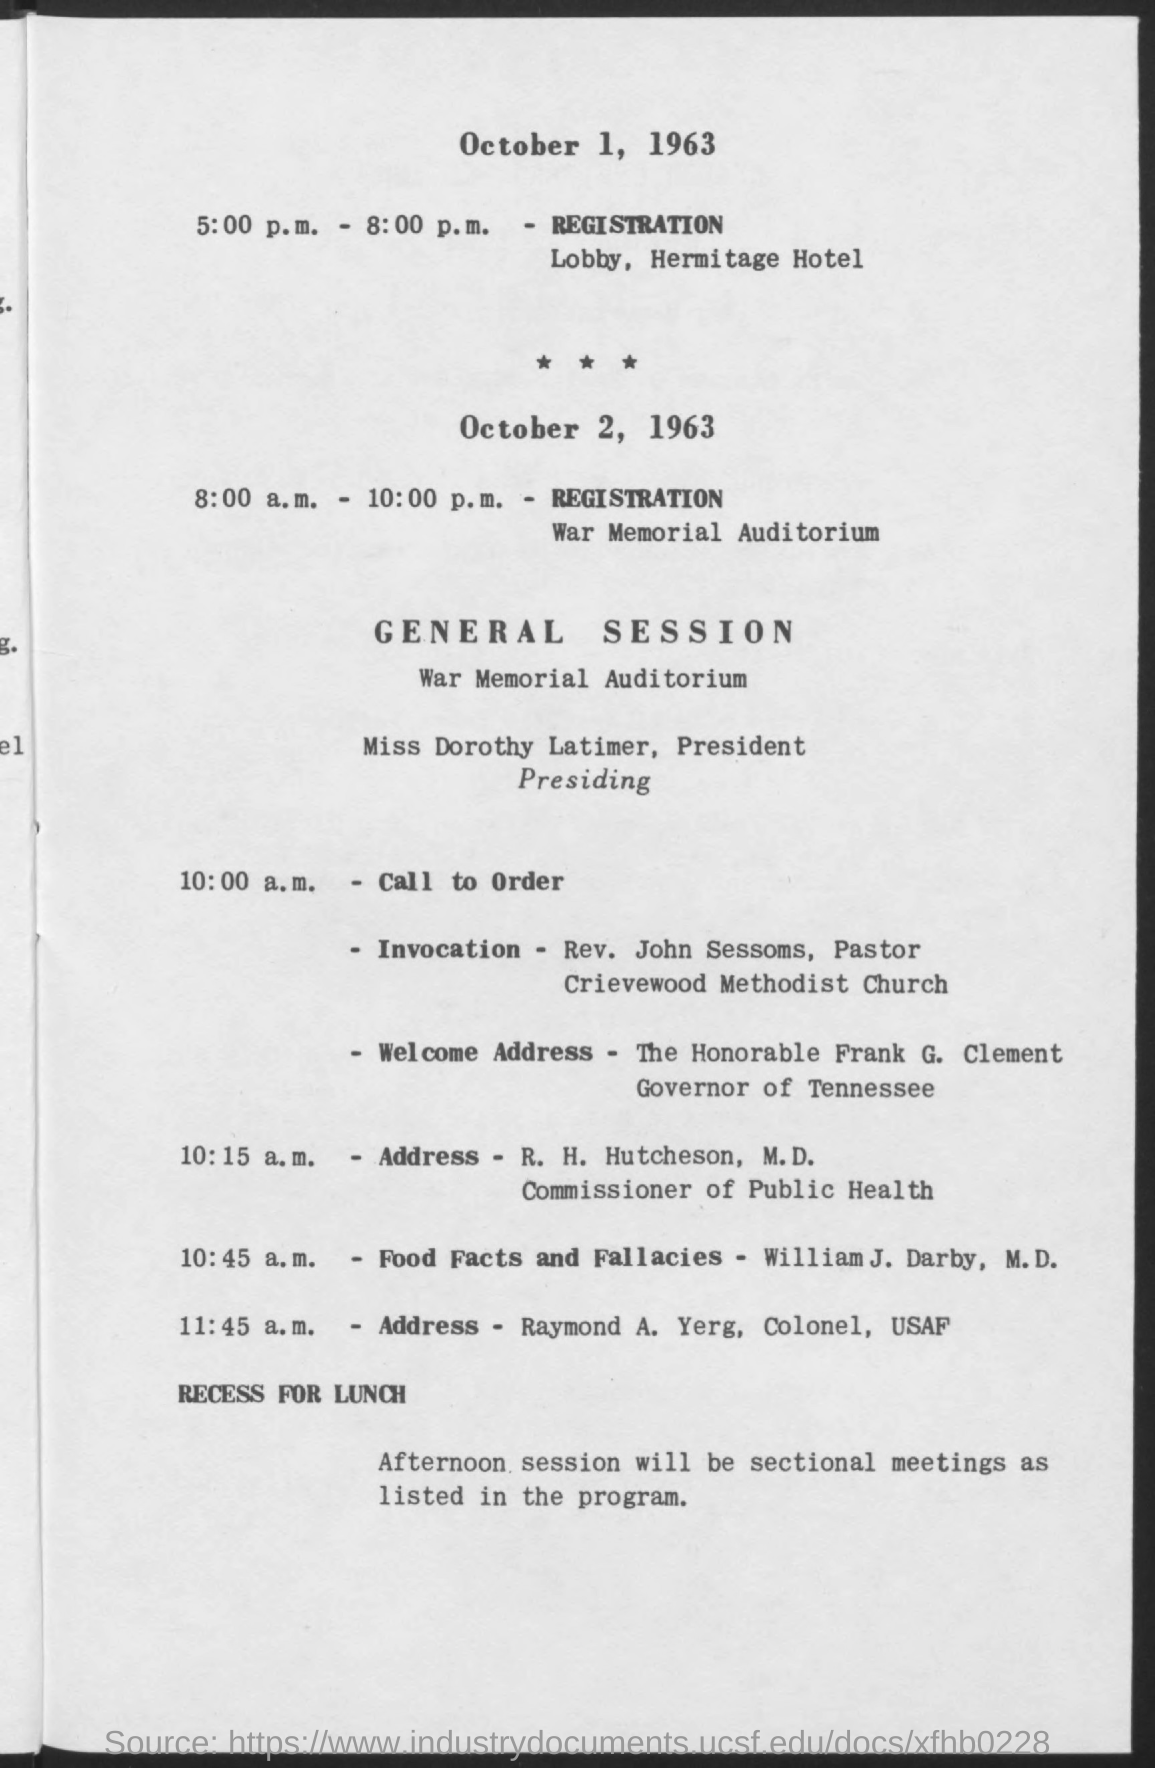Draw attention to some important aspects in this diagram. The address by Raymond A. Yerg, Colonel, USAF, is scheduled to take place at 11:45 a.m. On October 1, 1963, the registration took place from 5:00 p.m. to 8:00 p.m. The Governor of Tennessee is Frank G. Clement, who is honored for his service. On October 1, 1963, the registration took place in the lobby of the Hermitage Hotel. The registration took place on October 2, 1963, from 8:00 a.m. to 10:00 p.m. 